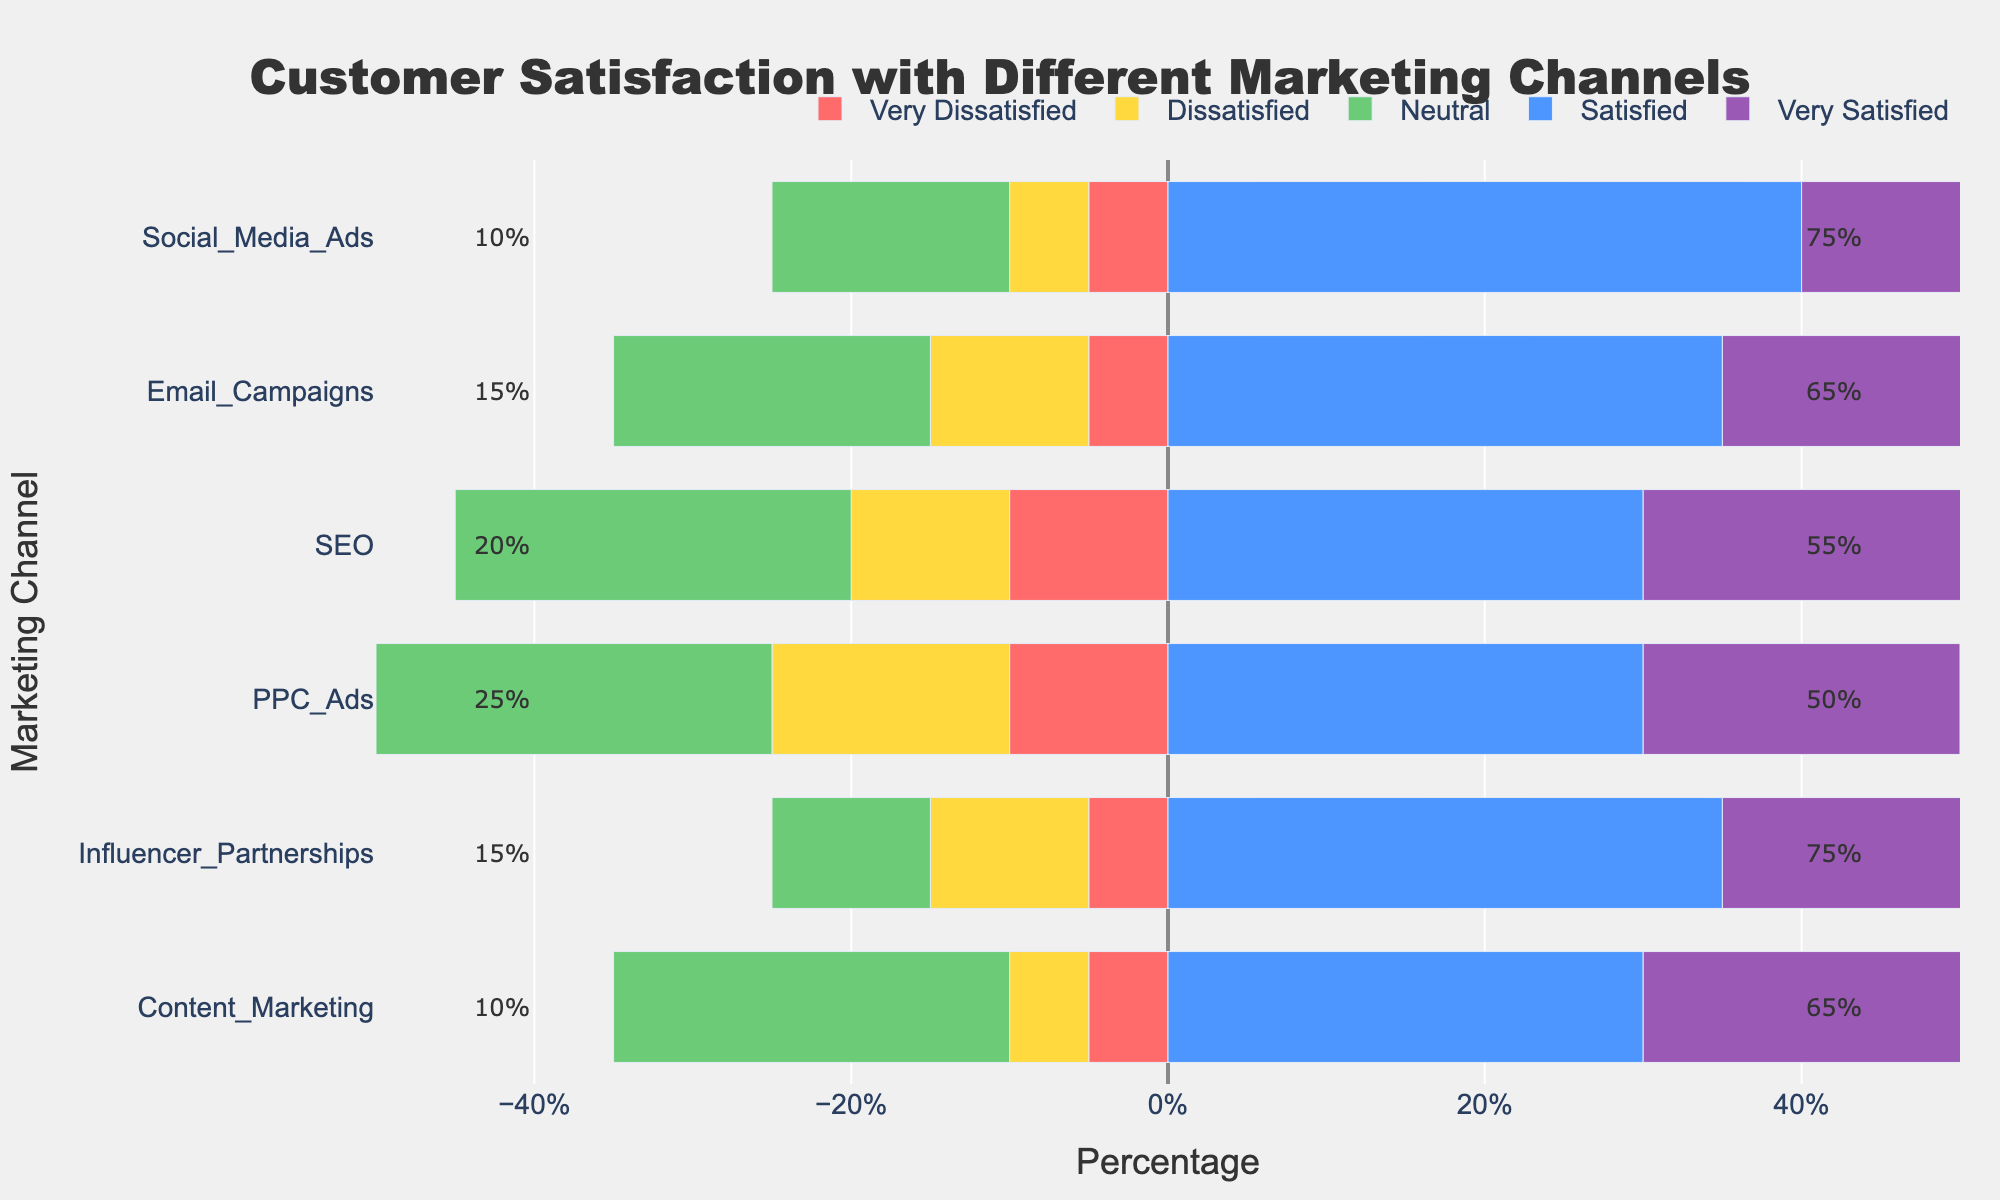Which marketing channel has the highest percentage of neutral satisfaction? The bar corresponding to 'Neutral' satisfaction will be examined for each channel. By looking at the lengths, SEO and PPC Ads have the longest bars. Comparing them shows they both have the same values.
Answer: SEO and PPC Ads Which marketing channel has the smallest percentage of very satisfied customers? The bar corresponding to 'Very Satisfied' satisfaction will be checked for its length for each channel. PPC Ads have the shortest bar for 'Very Satisfied' category.
Answer: PPC Ads Among the Email Campaigns, what is the difference between very satisfied and very dissatisfied customers? The 'Very Satisfied' percentage for Email Campaigns is 30, while 'Very Dissatisfied' is 5. Subtract the smaller value from the larger value (30 - 5).
Answer: 25 Which marketing channel has the highest overall satisfaction (sum of Satisfied and Very Satisfied)? Add the 'Satisfied' and 'Very Satisfied' percentages for each channel. The sum for Influencer_Partnerships is 40 + 35 = 75 (highest).
Answer: Influencer Partnerships How does the satisfaction level between Social Media Ads and Influencer Partnerships compare? Compare the bars for 'Very Satisfied' and 'Satisfied' categories of both channels. Social Media Ads have 35 'Very Satisfied' and 40 'Satisfied,' whereas Influencer Partnerships have 40 and 35 respectively. Both have the same overall satisfaction (75), thus equal for total satisfied.
Answer: Equal for total satisfied What percentage of customers are dissatisfied (sum of Dissatisfied and Very Dissatisfied) with Content Marketing? Add 'Dissatisfied' and 'Very Dissatisfied' percentages for Content Marketing: 5 + 5 = 10.
Answer: 10% Which channel has the largest percentage of customers who are either very dissatisfied or very satisfied? Compare the two ends 'Very Dissatisfied' and 'Very Satisfied' for each channel. Influencer Partnerships have the largest percentage for 'Very Satisfied', thus having the highest combined impact.
Answer: Influencer Partnerships How does the combined percentage of dissatisfied and very dissatisfied customers compare between SEO and PPC Ads? For SEO, (10 + 10 = 20); for PPC Ads, (15 + 10 = 25). Comparing these combined values shows more for PPC Ads.
Answer: PPC Ads has 5% more What is the percentage difference in neutral satisfaction between Social Media Ads and Email Campaigns? For Social Media Ads, 'Neutral' is 15; for Email Campaigns, it is 20. The difference is calculated as 20 - 15.
Answer: 5% Which marketing channel shows the greatest variance between customer satisfaction levels? Variance can be visually approximated by examining the length difference between the tallest and shortest bars for each channel. 'Very Satisfied' and 'Very Dissatisfied' show the widest range for PPC Ads.
Answer: PPC Ads 